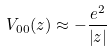<formula> <loc_0><loc_0><loc_500><loc_500>V _ { 0 0 } ( z ) \approx - \frac { e ^ { 2 } } { \left | z \right | }</formula> 